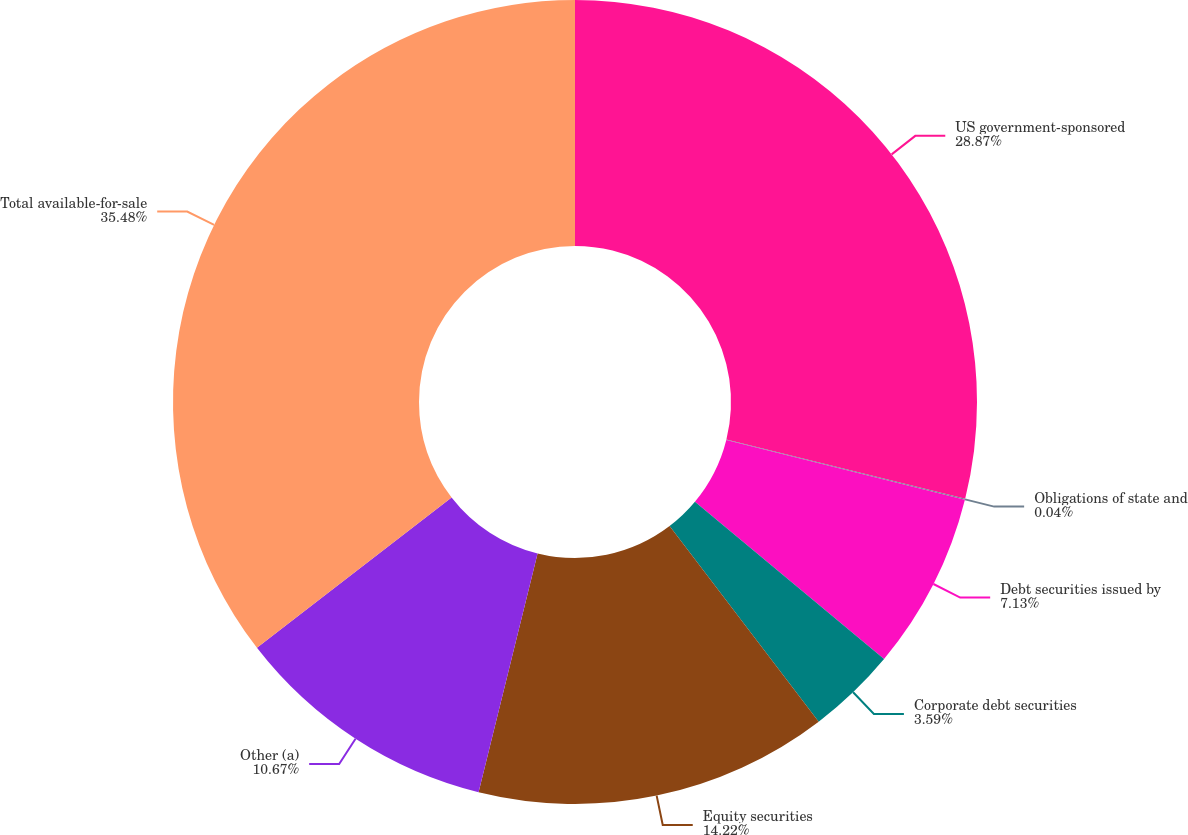<chart> <loc_0><loc_0><loc_500><loc_500><pie_chart><fcel>US government-sponsored<fcel>Obligations of state and<fcel>Debt securities issued by<fcel>Corporate debt securities<fcel>Equity securities<fcel>Other (a)<fcel>Total available-for-sale<nl><fcel>28.87%<fcel>0.04%<fcel>7.13%<fcel>3.59%<fcel>14.22%<fcel>10.67%<fcel>35.47%<nl></chart> 